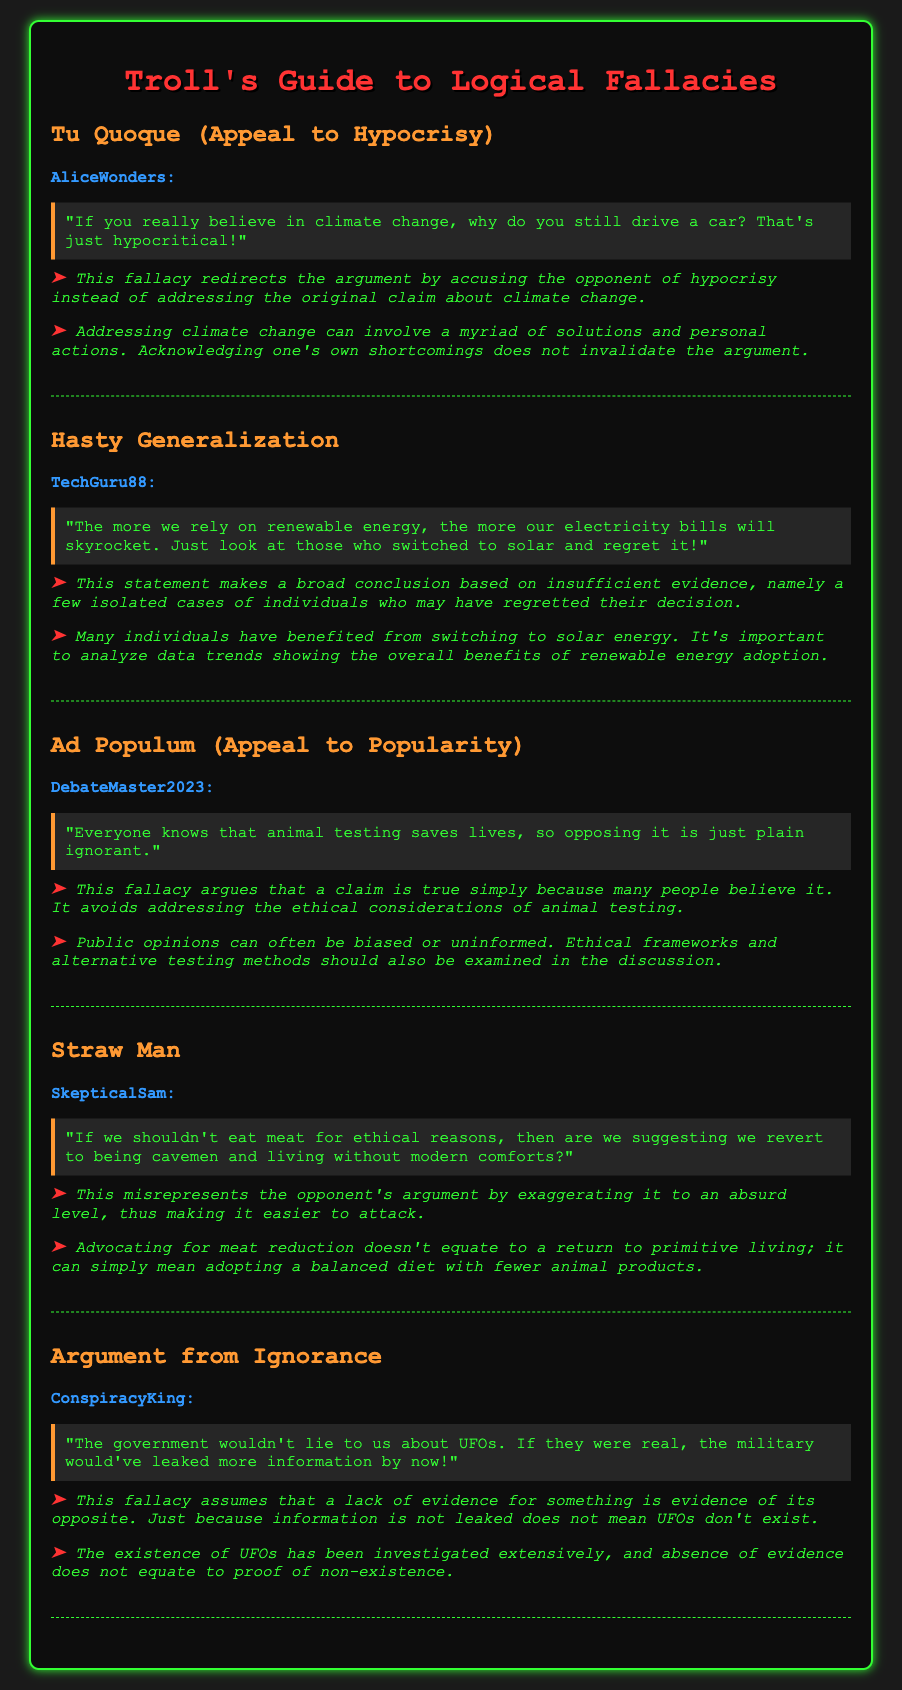What logical fallacy does AliceWonders use? AliceWonders uses the Tu Quoque fallacy, which is an appeal to hypocrisy.
Answer: Tu Quoque Who is the participant making a Hasty Generalization? The participant making a Hasty Generalization is TechGuru88.
Answer: TechGuru88 What does DebateMaster2023 claim about animal testing? DebateMaster2023 claims that animal testing saves lives, suggesting that opposing it is ignorant.
Answer: Saves lives What type of logical fallacy is attributed to SkepticalSam? SkepticalSam is attributed with the Straw Man fallacy.
Answer: Straw Man What does ConspiracyKing argue about UFOs? ConspiracyKing argues that the government wouldn't lie about UFOs and claims a lack of leaks indicates they don't exist.
Answer: Government wouldn't lie What is the annotation for the Ad Populum fallacy? The annotation for the Ad Populum fallacy notes that it argues a claim is true simply because many people believe it, avoiding ethical considerations.
Answer: Avoiding ethical considerations What fallacy does the post by TechGuru88 misrepresent? The post by TechGuru88 misrepresents the effectiveness of renewable energy solutions.
Answer: Effectiveness of renewable energy How does the counter-argument to AliceWonders' claim conclude? The counter-argument concludes that acknowledging one's shortcomings does not invalidate the argument.
Answer: Does not invalidate the argument 